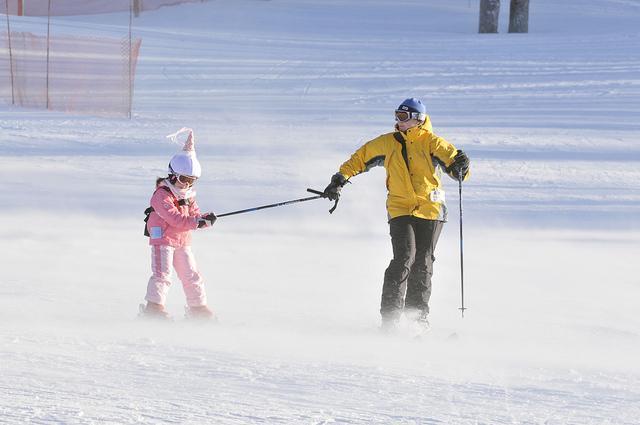How many people can you see?
Give a very brief answer. 2. 